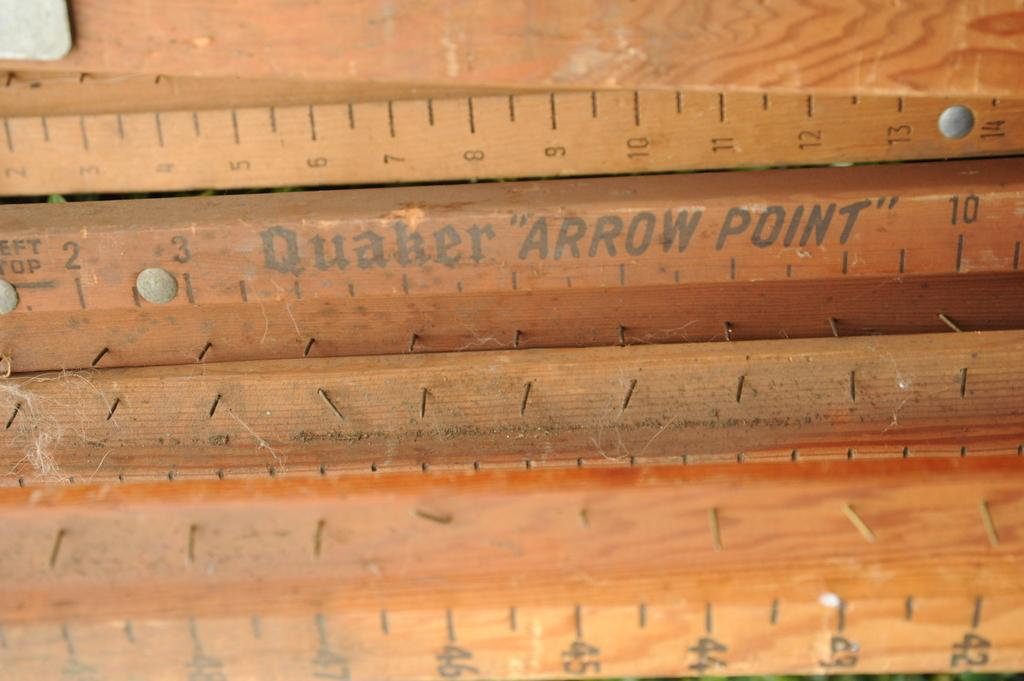Provide a one-sentence caption for the provided image. A bunch of rulers, one labeled Quaker Arrow Point. 